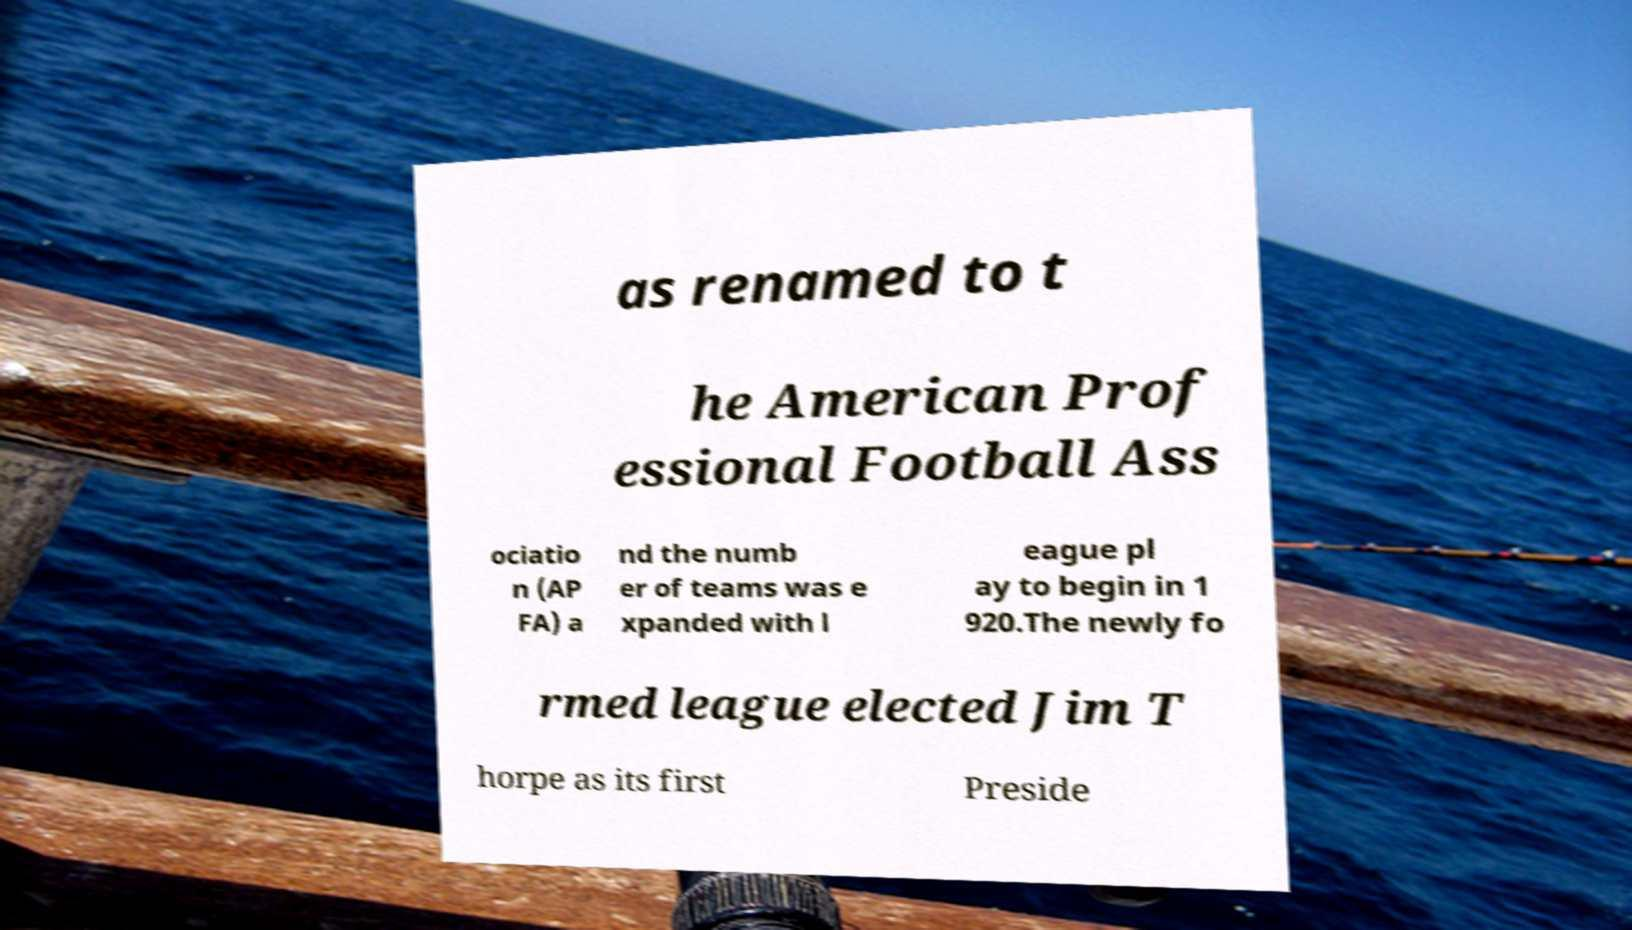I need the written content from this picture converted into text. Can you do that? as renamed to t he American Prof essional Football Ass ociatio n (AP FA) a nd the numb er of teams was e xpanded with l eague pl ay to begin in 1 920.The newly fo rmed league elected Jim T horpe as its first Preside 